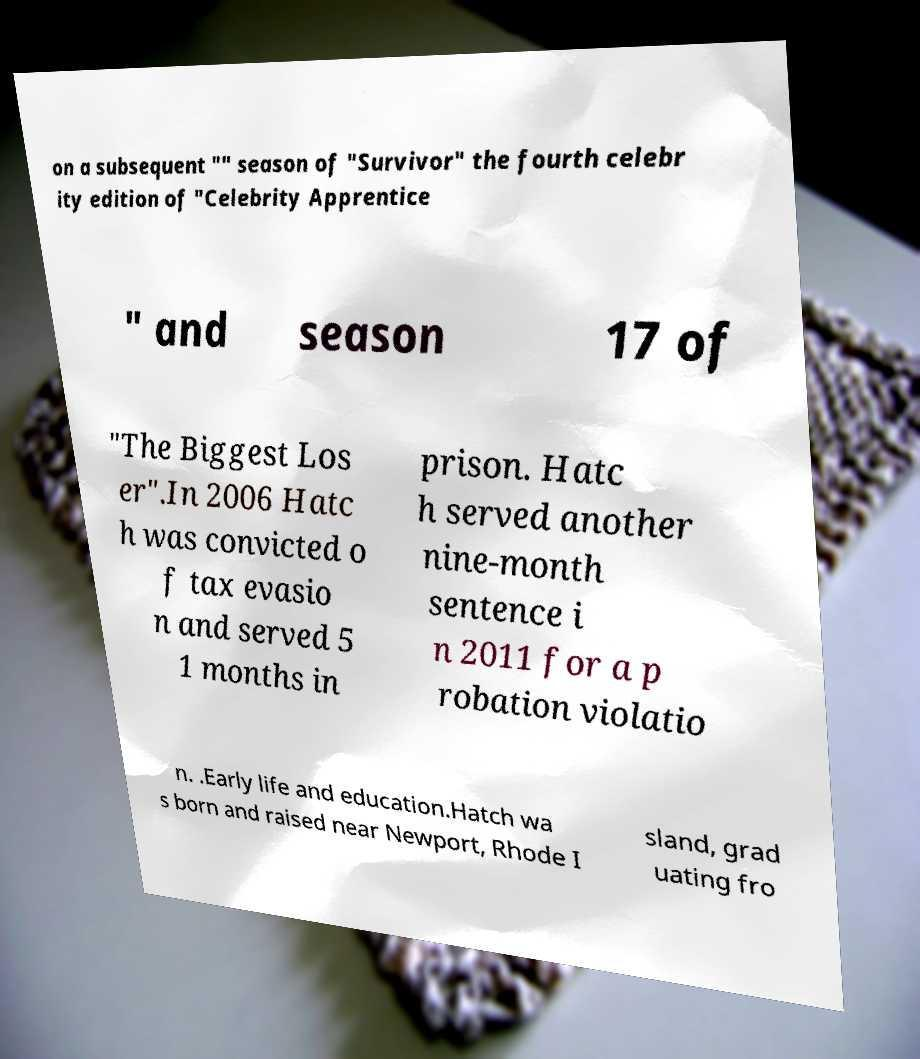Can you read and provide the text displayed in the image?This photo seems to have some interesting text. Can you extract and type it out for me? on a subsequent "" season of "Survivor" the fourth celebr ity edition of "Celebrity Apprentice " and season 17 of "The Biggest Los er".In 2006 Hatc h was convicted o f tax evasio n and served 5 1 months in prison. Hatc h served another nine-month sentence i n 2011 for a p robation violatio n. .Early life and education.Hatch wa s born and raised near Newport, Rhode I sland, grad uating fro 